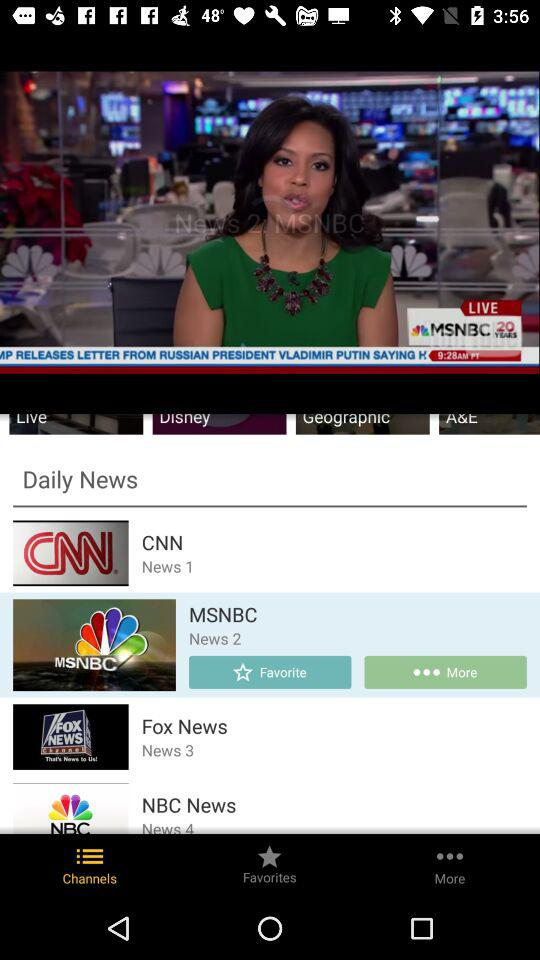Which news channel is marked favorite?
When the provided information is insufficient, respond with <no answer>. <no answer> 